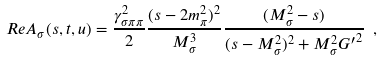Convert formula to latex. <formula><loc_0><loc_0><loc_500><loc_500>R e A _ { \sigma } ( s , t , u ) = \frac { \gamma _ { \sigma \pi \pi } ^ { 2 } } { 2 } \frac { ( s - 2 m _ { \pi } ^ { 2 } ) ^ { 2 } } { M ^ { 3 } _ { \sigma } } \frac { ( M _ { \sigma } ^ { 2 } - s ) } { ( s - M _ { \sigma } ^ { 2 } ) ^ { 2 } + M _ { \sigma } ^ { 2 } { G ^ { \prime } } ^ { 2 } } \ ,</formula> 